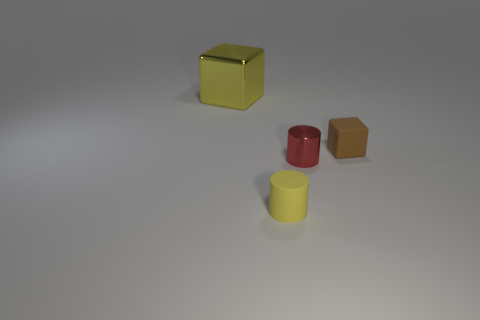Subtract all yellow cylinders. Subtract all green blocks. How many cylinders are left? 1 Add 3 large brown shiny cylinders. How many objects exist? 7 Add 4 large yellow shiny cylinders. How many large yellow shiny cylinders exist? 4 Subtract 0 green cylinders. How many objects are left? 4 Subtract all big brown rubber things. Subtract all yellow blocks. How many objects are left? 3 Add 2 tiny yellow rubber cylinders. How many tiny yellow rubber cylinders are left? 3 